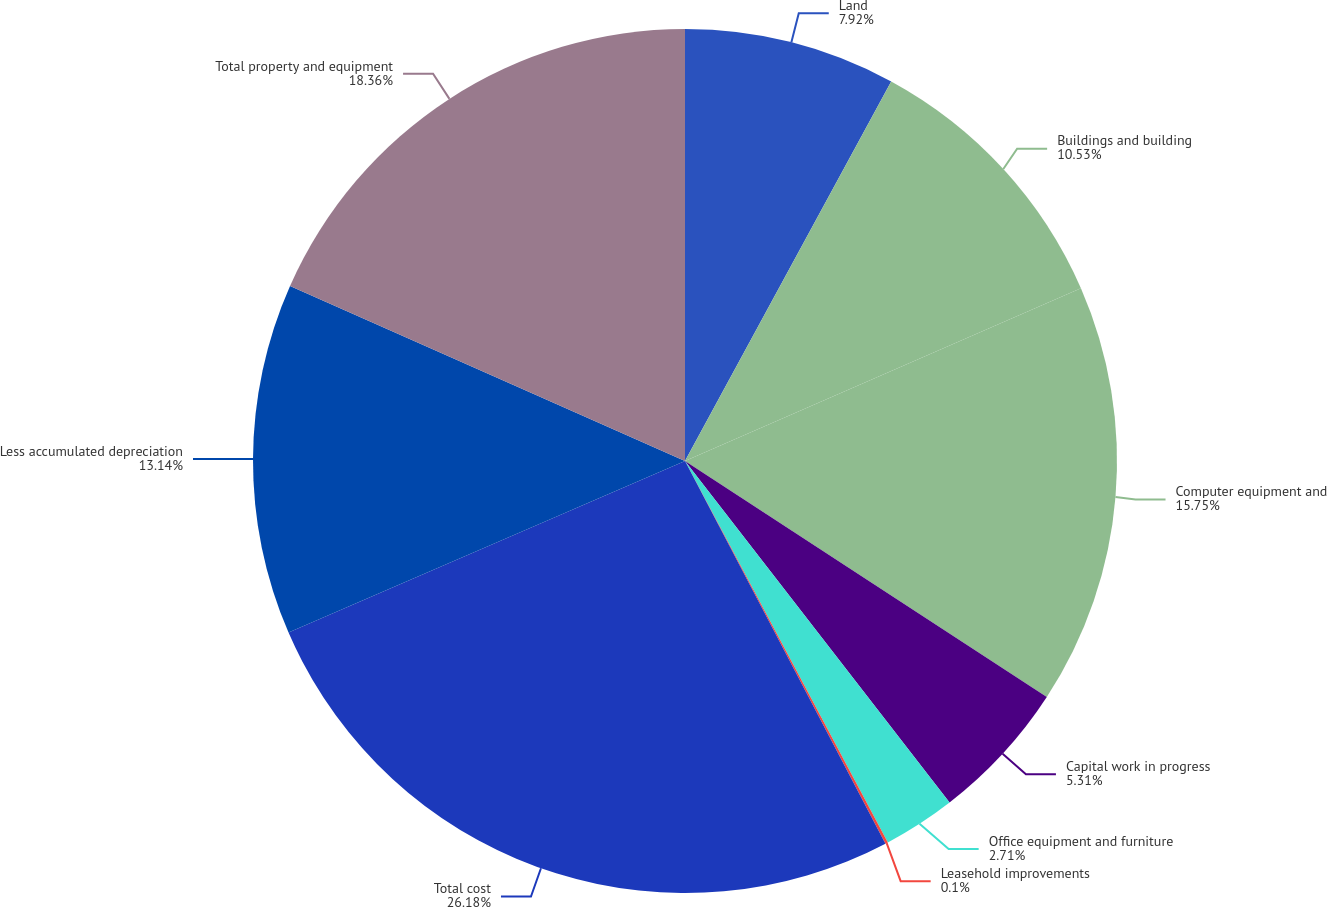Convert chart to OTSL. <chart><loc_0><loc_0><loc_500><loc_500><pie_chart><fcel>Land<fcel>Buildings and building<fcel>Computer equipment and<fcel>Capital work in progress<fcel>Office equipment and furniture<fcel>Leasehold improvements<fcel>Total cost<fcel>Less accumulated depreciation<fcel>Total property and equipment<nl><fcel>7.92%<fcel>10.53%<fcel>15.75%<fcel>5.31%<fcel>2.71%<fcel>0.1%<fcel>26.18%<fcel>13.14%<fcel>18.36%<nl></chart> 